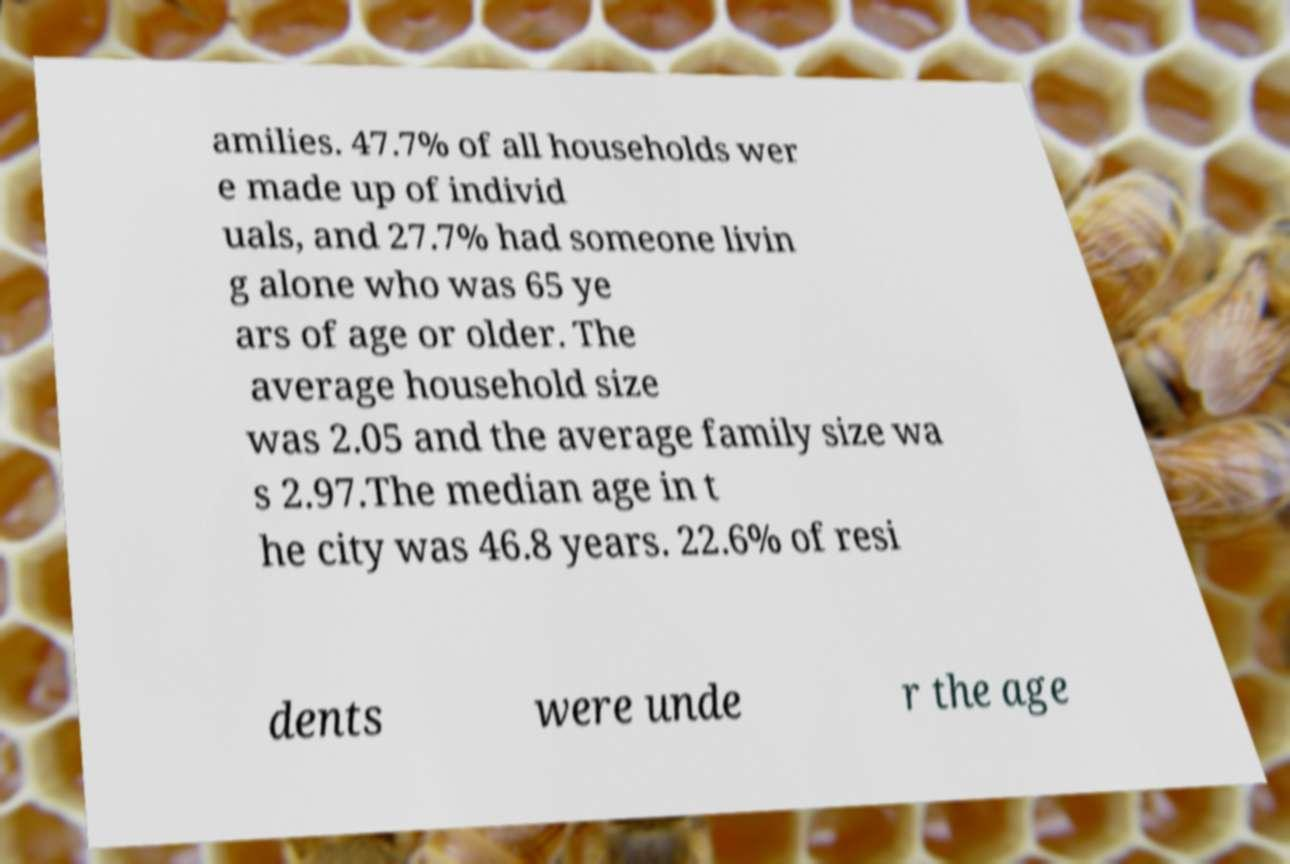Could you assist in decoding the text presented in this image and type it out clearly? amilies. 47.7% of all households wer e made up of individ uals, and 27.7% had someone livin g alone who was 65 ye ars of age or older. The average household size was 2.05 and the average family size wa s 2.97.The median age in t he city was 46.8 years. 22.6% of resi dents were unde r the age 